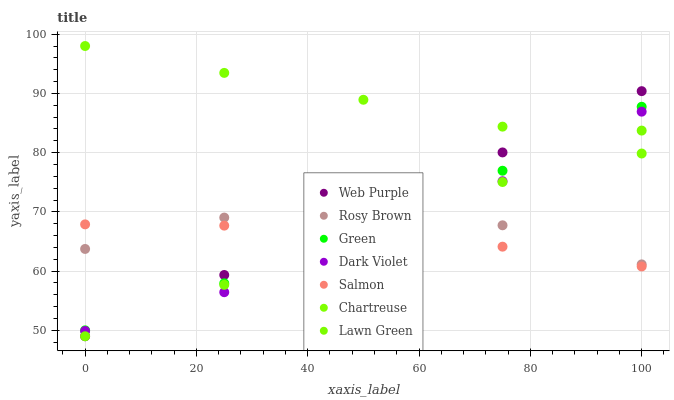Does Salmon have the minimum area under the curve?
Answer yes or no. Yes. Does Chartreuse have the maximum area under the curve?
Answer yes or no. Yes. Does Rosy Brown have the minimum area under the curve?
Answer yes or no. No. Does Rosy Brown have the maximum area under the curve?
Answer yes or no. No. Is Lawn Green the smoothest?
Answer yes or no. Yes. Is Rosy Brown the roughest?
Answer yes or no. Yes. Is Salmon the smoothest?
Answer yes or no. No. Is Salmon the roughest?
Answer yes or no. No. Does Lawn Green have the lowest value?
Answer yes or no. Yes. Does Rosy Brown have the lowest value?
Answer yes or no. No. Does Chartreuse have the highest value?
Answer yes or no. Yes. Does Rosy Brown have the highest value?
Answer yes or no. No. Is Salmon less than Chartreuse?
Answer yes or no. Yes. Is Green greater than Lawn Green?
Answer yes or no. Yes. Does Web Purple intersect Green?
Answer yes or no. Yes. Is Web Purple less than Green?
Answer yes or no. No. Is Web Purple greater than Green?
Answer yes or no. No. Does Salmon intersect Chartreuse?
Answer yes or no. No. 